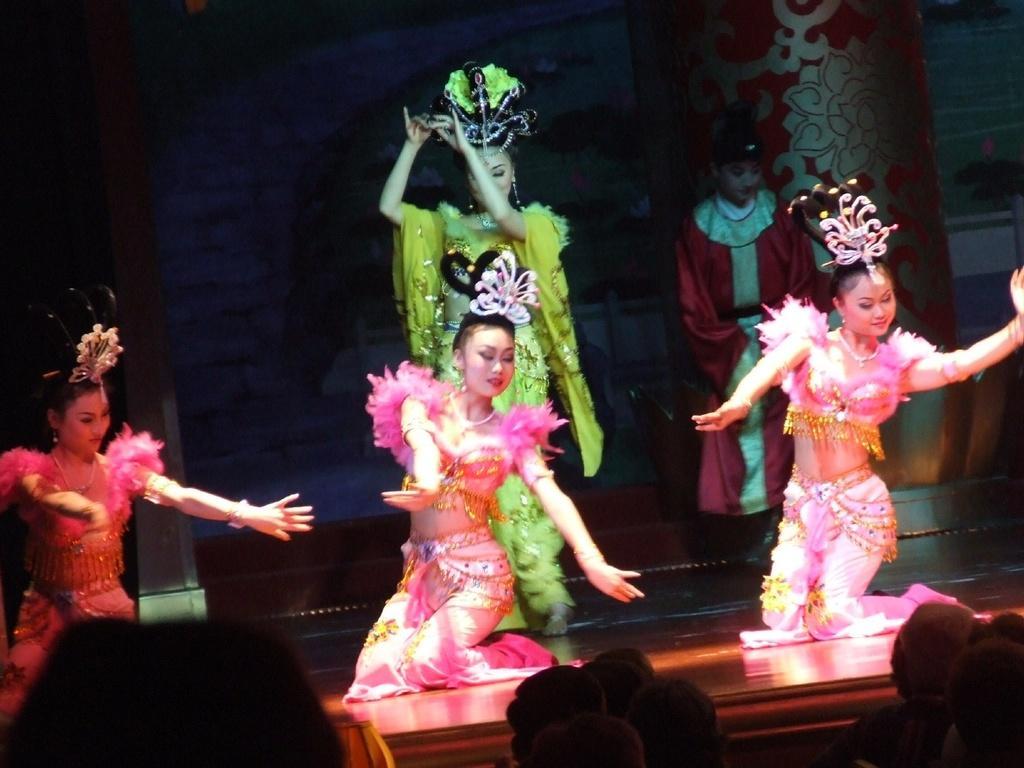In one or two sentences, can you explain what this image depicts? In this image, there are some girls dancing on the floor and there are two girls standing, there are some people sitting and they are watching the dance. 